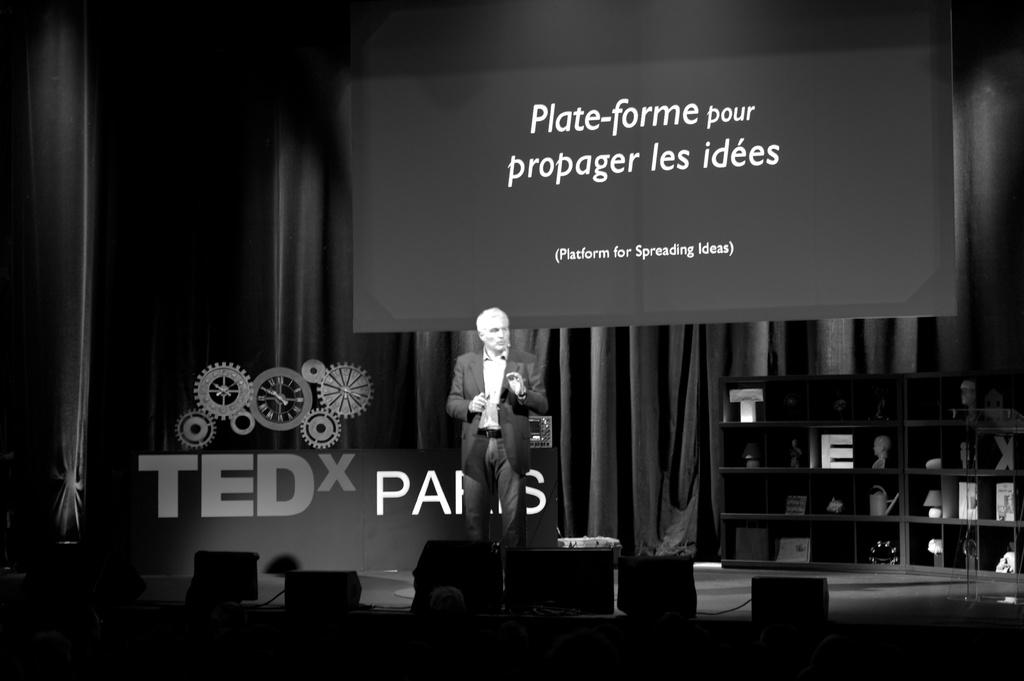What is hanging in the image? There is a banner in the image. What can be used to hold items in the image? There is a rack in the image. What type of window treatment is present in the image? There are curtains in the image. What device is visible in the image? There is a screen in the image. What is the person in the image wearing? The person is wearing a black color jacket in the image. How would you describe the lighting in the image? The image is a little dark. Can you tell me where the stove is located in the image? There is no stove present in the image. What type of lead is being used by the person in the image? There is no mention of any lead or leadership role in the image; it only shows a person wearing a black jacket. 